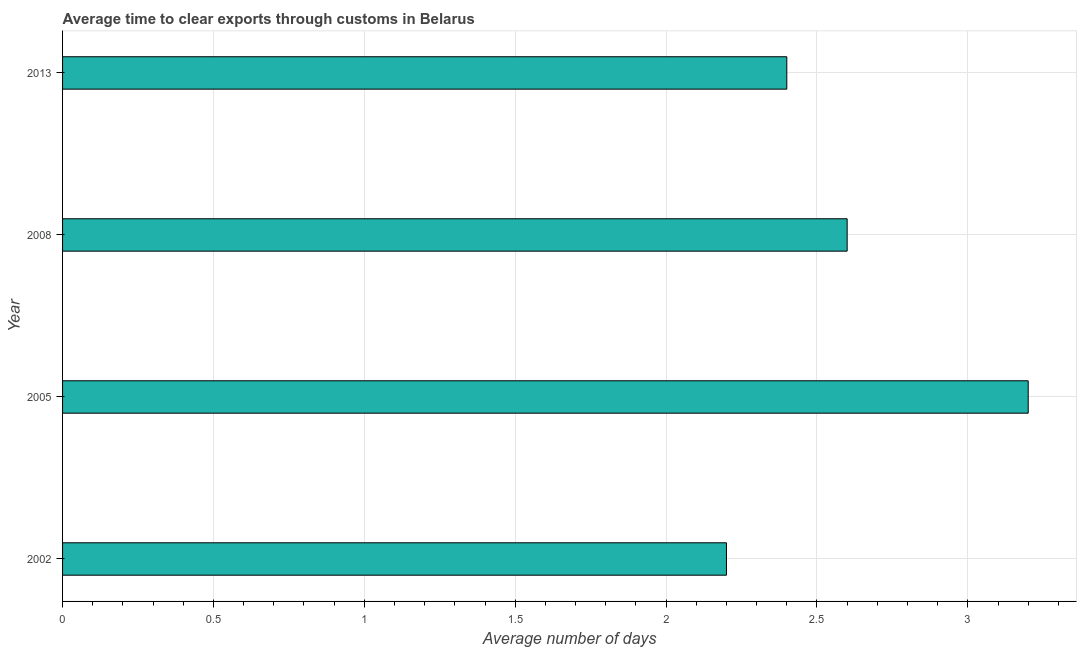What is the title of the graph?
Ensure brevity in your answer.  Average time to clear exports through customs in Belarus. What is the label or title of the X-axis?
Your answer should be very brief. Average number of days. Across all years, what is the minimum time to clear exports through customs?
Keep it short and to the point. 2.2. What is the difference between the time to clear exports through customs in 2008 and 2013?
Ensure brevity in your answer.  0.2. What is the average time to clear exports through customs per year?
Offer a very short reply. 2.6. What is the median time to clear exports through customs?
Offer a terse response. 2.5. What is the ratio of the time to clear exports through customs in 2002 to that in 2008?
Ensure brevity in your answer.  0.85. Is the time to clear exports through customs in 2005 less than that in 2013?
Your response must be concise. No. What is the difference between the highest and the second highest time to clear exports through customs?
Offer a very short reply. 0.6. Is the sum of the time to clear exports through customs in 2008 and 2013 greater than the maximum time to clear exports through customs across all years?
Offer a terse response. Yes. In how many years, is the time to clear exports through customs greater than the average time to clear exports through customs taken over all years?
Keep it short and to the point. 1. How many bars are there?
Ensure brevity in your answer.  4. Are all the bars in the graph horizontal?
Offer a terse response. Yes. How many years are there in the graph?
Your answer should be compact. 4. What is the Average number of days of 2013?
Ensure brevity in your answer.  2.4. What is the difference between the Average number of days in 2002 and 2005?
Give a very brief answer. -1. What is the difference between the Average number of days in 2002 and 2013?
Give a very brief answer. -0.2. What is the ratio of the Average number of days in 2002 to that in 2005?
Your answer should be very brief. 0.69. What is the ratio of the Average number of days in 2002 to that in 2008?
Ensure brevity in your answer.  0.85. What is the ratio of the Average number of days in 2002 to that in 2013?
Your response must be concise. 0.92. What is the ratio of the Average number of days in 2005 to that in 2008?
Provide a short and direct response. 1.23. What is the ratio of the Average number of days in 2005 to that in 2013?
Ensure brevity in your answer.  1.33. What is the ratio of the Average number of days in 2008 to that in 2013?
Provide a succinct answer. 1.08. 